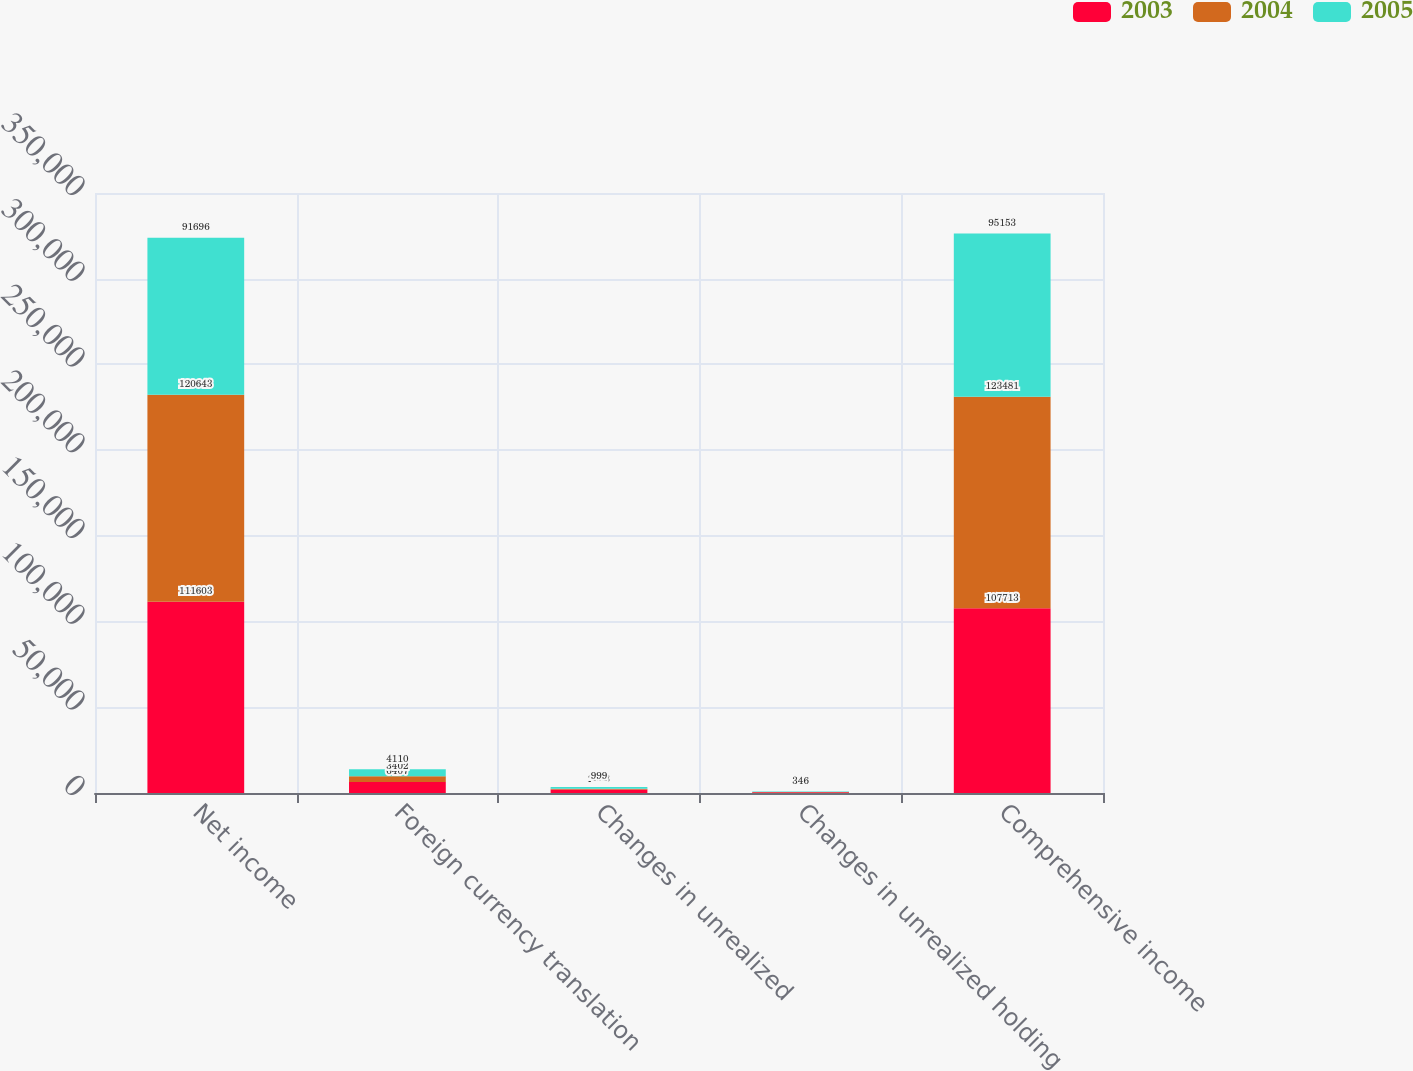<chart> <loc_0><loc_0><loc_500><loc_500><stacked_bar_chart><ecel><fcel>Net income<fcel>Foreign currency translation<fcel>Changes in unrealized<fcel>Changes in unrealized holding<fcel>Comprehensive income<nl><fcel>2003<fcel>111603<fcel>6407<fcel>2073<fcel>444<fcel>107713<nl><fcel>2004<fcel>120643<fcel>3402<fcel>451<fcel>113<fcel>123481<nl><fcel>2005<fcel>91696<fcel>4110<fcel>999<fcel>346<fcel>95153<nl></chart> 